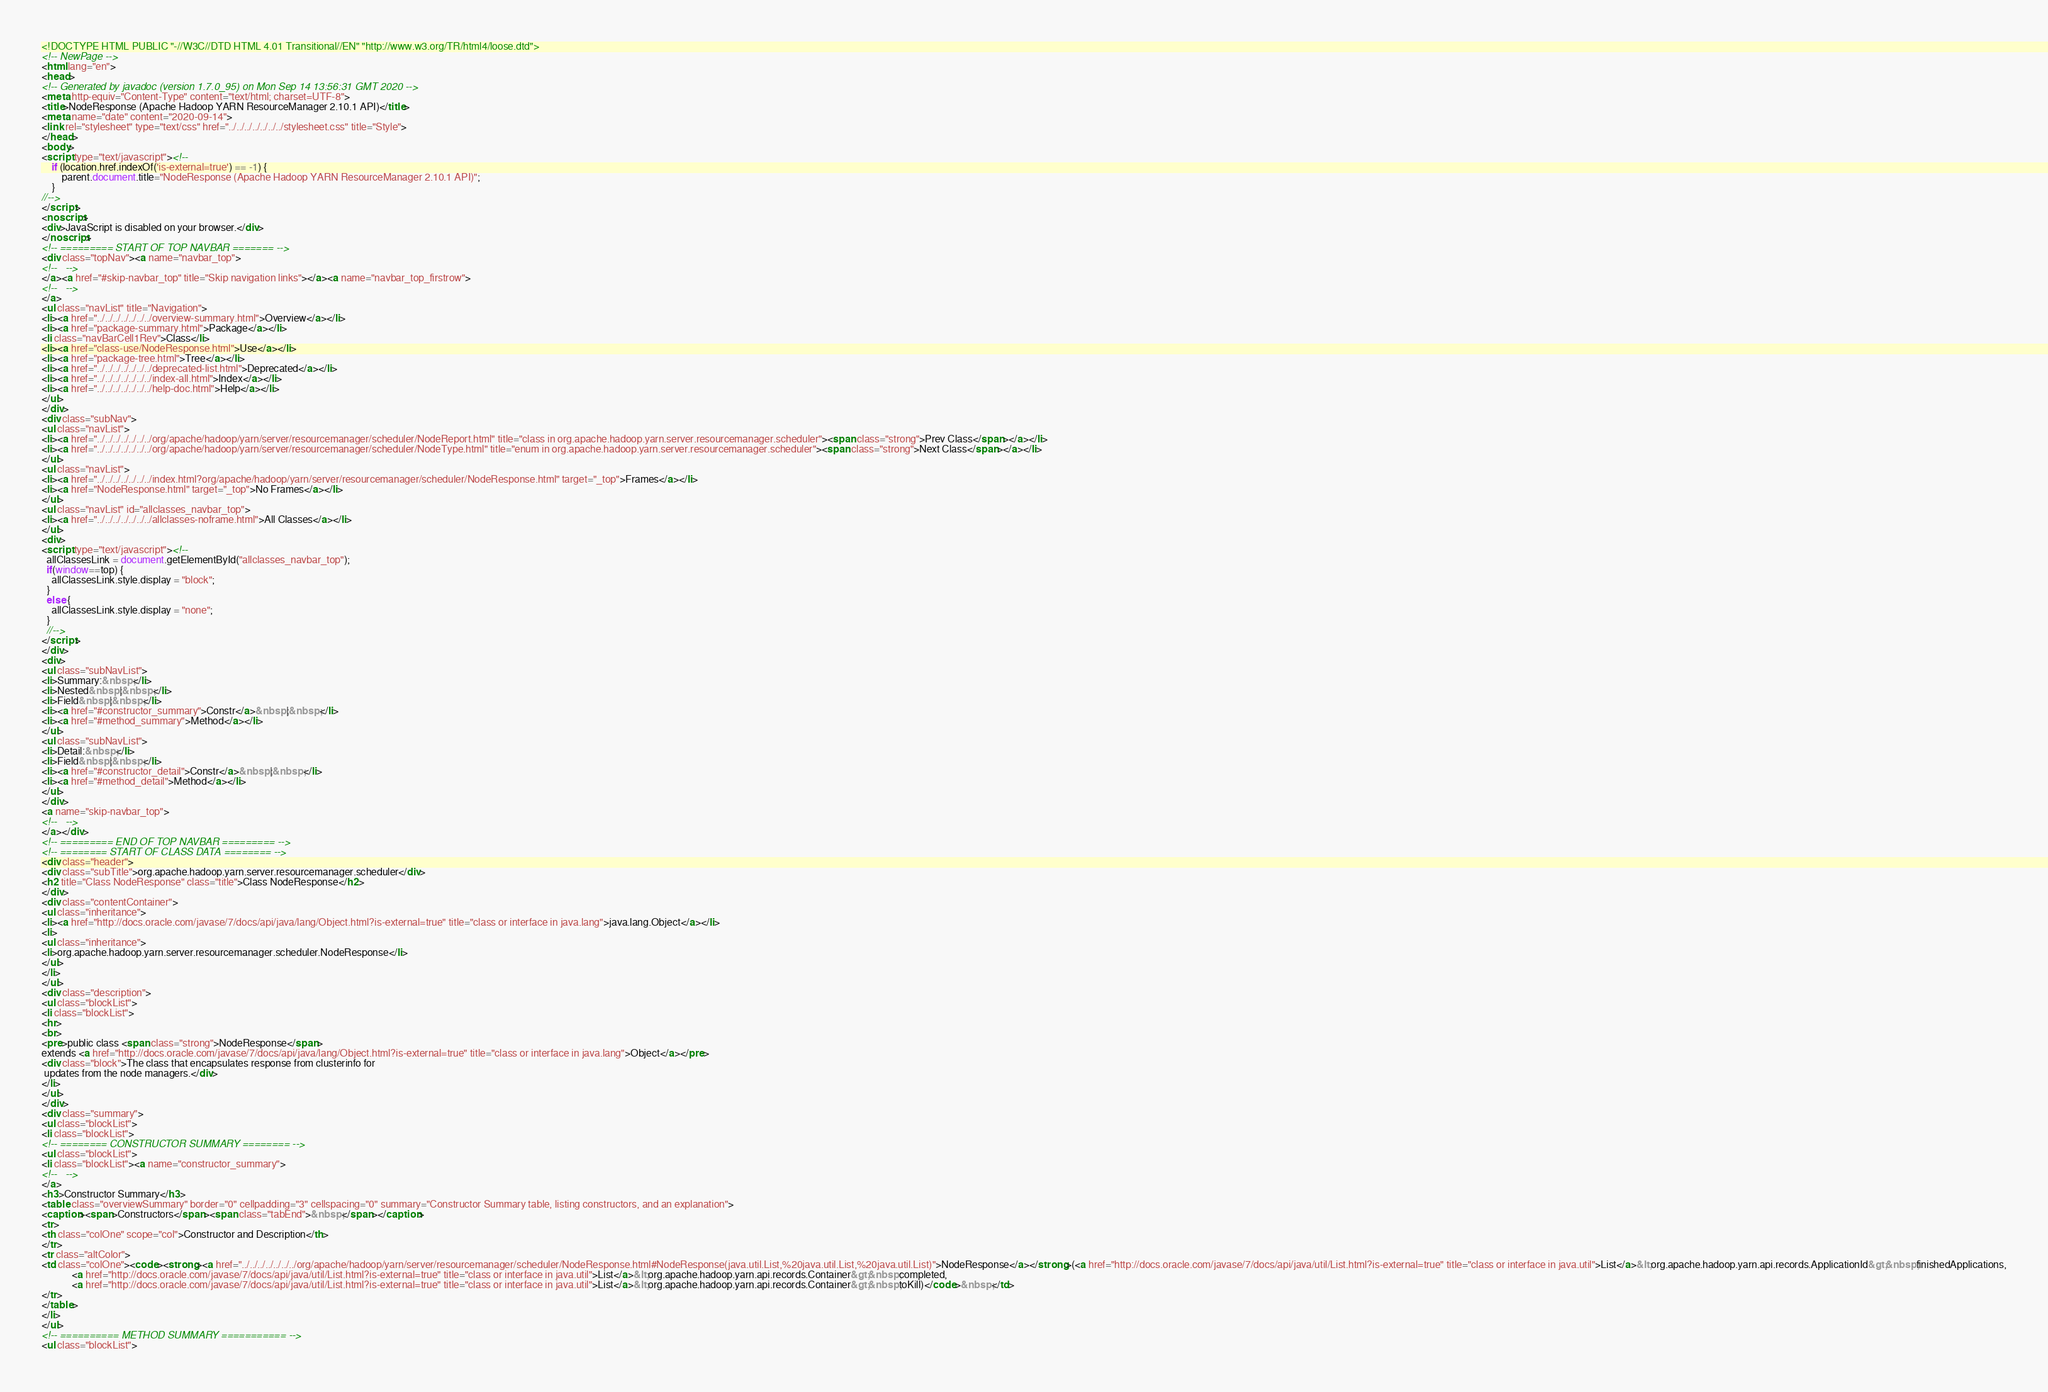<code> <loc_0><loc_0><loc_500><loc_500><_HTML_><!DOCTYPE HTML PUBLIC "-//W3C//DTD HTML 4.01 Transitional//EN" "http://www.w3.org/TR/html4/loose.dtd">
<!-- NewPage -->
<html lang="en">
<head>
<!-- Generated by javadoc (version 1.7.0_95) on Mon Sep 14 13:56:31 GMT 2020 -->
<meta http-equiv="Content-Type" content="text/html; charset=UTF-8">
<title>NodeResponse (Apache Hadoop YARN ResourceManager 2.10.1 API)</title>
<meta name="date" content="2020-09-14">
<link rel="stylesheet" type="text/css" href="../../../../../../../stylesheet.css" title="Style">
</head>
<body>
<script type="text/javascript"><!--
    if (location.href.indexOf('is-external=true') == -1) {
        parent.document.title="NodeResponse (Apache Hadoop YARN ResourceManager 2.10.1 API)";
    }
//-->
</script>
<noscript>
<div>JavaScript is disabled on your browser.</div>
</noscript>
<!-- ========= START OF TOP NAVBAR ======= -->
<div class="topNav"><a name="navbar_top">
<!--   -->
</a><a href="#skip-navbar_top" title="Skip navigation links"></a><a name="navbar_top_firstrow">
<!--   -->
</a>
<ul class="navList" title="Navigation">
<li><a href="../../../../../../../overview-summary.html">Overview</a></li>
<li><a href="package-summary.html">Package</a></li>
<li class="navBarCell1Rev">Class</li>
<li><a href="class-use/NodeResponse.html">Use</a></li>
<li><a href="package-tree.html">Tree</a></li>
<li><a href="../../../../../../../deprecated-list.html">Deprecated</a></li>
<li><a href="../../../../../../../index-all.html">Index</a></li>
<li><a href="../../../../../../../help-doc.html">Help</a></li>
</ul>
</div>
<div class="subNav">
<ul class="navList">
<li><a href="../../../../../../../org/apache/hadoop/yarn/server/resourcemanager/scheduler/NodeReport.html" title="class in org.apache.hadoop.yarn.server.resourcemanager.scheduler"><span class="strong">Prev Class</span></a></li>
<li><a href="../../../../../../../org/apache/hadoop/yarn/server/resourcemanager/scheduler/NodeType.html" title="enum in org.apache.hadoop.yarn.server.resourcemanager.scheduler"><span class="strong">Next Class</span></a></li>
</ul>
<ul class="navList">
<li><a href="../../../../../../../index.html?org/apache/hadoop/yarn/server/resourcemanager/scheduler/NodeResponse.html" target="_top">Frames</a></li>
<li><a href="NodeResponse.html" target="_top">No Frames</a></li>
</ul>
<ul class="navList" id="allclasses_navbar_top">
<li><a href="../../../../../../../allclasses-noframe.html">All Classes</a></li>
</ul>
<div>
<script type="text/javascript"><!--
  allClassesLink = document.getElementById("allclasses_navbar_top");
  if(window==top) {
    allClassesLink.style.display = "block";
  }
  else {
    allClassesLink.style.display = "none";
  }
  //-->
</script>
</div>
<div>
<ul class="subNavList">
<li>Summary:&nbsp;</li>
<li>Nested&nbsp;|&nbsp;</li>
<li>Field&nbsp;|&nbsp;</li>
<li><a href="#constructor_summary">Constr</a>&nbsp;|&nbsp;</li>
<li><a href="#method_summary">Method</a></li>
</ul>
<ul class="subNavList">
<li>Detail:&nbsp;</li>
<li>Field&nbsp;|&nbsp;</li>
<li><a href="#constructor_detail">Constr</a>&nbsp;|&nbsp;</li>
<li><a href="#method_detail">Method</a></li>
</ul>
</div>
<a name="skip-navbar_top">
<!--   -->
</a></div>
<!-- ========= END OF TOP NAVBAR ========= -->
<!-- ======== START OF CLASS DATA ======== -->
<div class="header">
<div class="subTitle">org.apache.hadoop.yarn.server.resourcemanager.scheduler</div>
<h2 title="Class NodeResponse" class="title">Class NodeResponse</h2>
</div>
<div class="contentContainer">
<ul class="inheritance">
<li><a href="http://docs.oracle.com/javase/7/docs/api/java/lang/Object.html?is-external=true" title="class or interface in java.lang">java.lang.Object</a></li>
<li>
<ul class="inheritance">
<li>org.apache.hadoop.yarn.server.resourcemanager.scheduler.NodeResponse</li>
</ul>
</li>
</ul>
<div class="description">
<ul class="blockList">
<li class="blockList">
<hr>
<br>
<pre>public class <span class="strong">NodeResponse</span>
extends <a href="http://docs.oracle.com/javase/7/docs/api/java/lang/Object.html?is-external=true" title="class or interface in java.lang">Object</a></pre>
<div class="block">The class that encapsulates response from clusterinfo for 
 updates from the node managers.</div>
</li>
</ul>
</div>
<div class="summary">
<ul class="blockList">
<li class="blockList">
<!-- ======== CONSTRUCTOR SUMMARY ======== -->
<ul class="blockList">
<li class="blockList"><a name="constructor_summary">
<!--   -->
</a>
<h3>Constructor Summary</h3>
<table class="overviewSummary" border="0" cellpadding="3" cellspacing="0" summary="Constructor Summary table, listing constructors, and an explanation">
<caption><span>Constructors</span><span class="tabEnd">&nbsp;</span></caption>
<tr>
<th class="colOne" scope="col">Constructor and Description</th>
</tr>
<tr class="altColor">
<td class="colOne"><code><strong><a href="../../../../../../../org/apache/hadoop/yarn/server/resourcemanager/scheduler/NodeResponse.html#NodeResponse(java.util.List,%20java.util.List,%20java.util.List)">NodeResponse</a></strong>(<a href="http://docs.oracle.com/javase/7/docs/api/java/util/List.html?is-external=true" title="class or interface in java.util">List</a>&lt;org.apache.hadoop.yarn.api.records.ApplicationId&gt;&nbsp;finishedApplications,
            <a href="http://docs.oracle.com/javase/7/docs/api/java/util/List.html?is-external=true" title="class or interface in java.util">List</a>&lt;org.apache.hadoop.yarn.api.records.Container&gt;&nbsp;completed,
            <a href="http://docs.oracle.com/javase/7/docs/api/java/util/List.html?is-external=true" title="class or interface in java.util">List</a>&lt;org.apache.hadoop.yarn.api.records.Container&gt;&nbsp;toKill)</code>&nbsp;</td>
</tr>
</table>
</li>
</ul>
<!-- ========== METHOD SUMMARY =========== -->
<ul class="blockList"></code> 